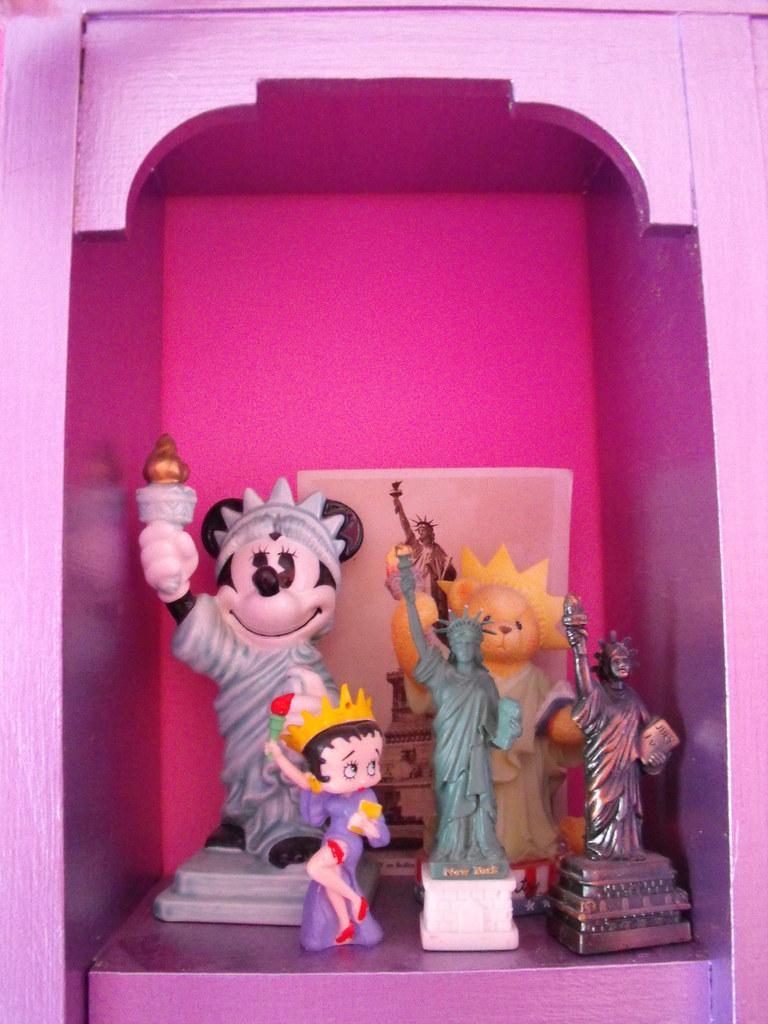How would you summarize this image in a sentence or two? Here in this picture we can see some dolls present in a wooden rack. 